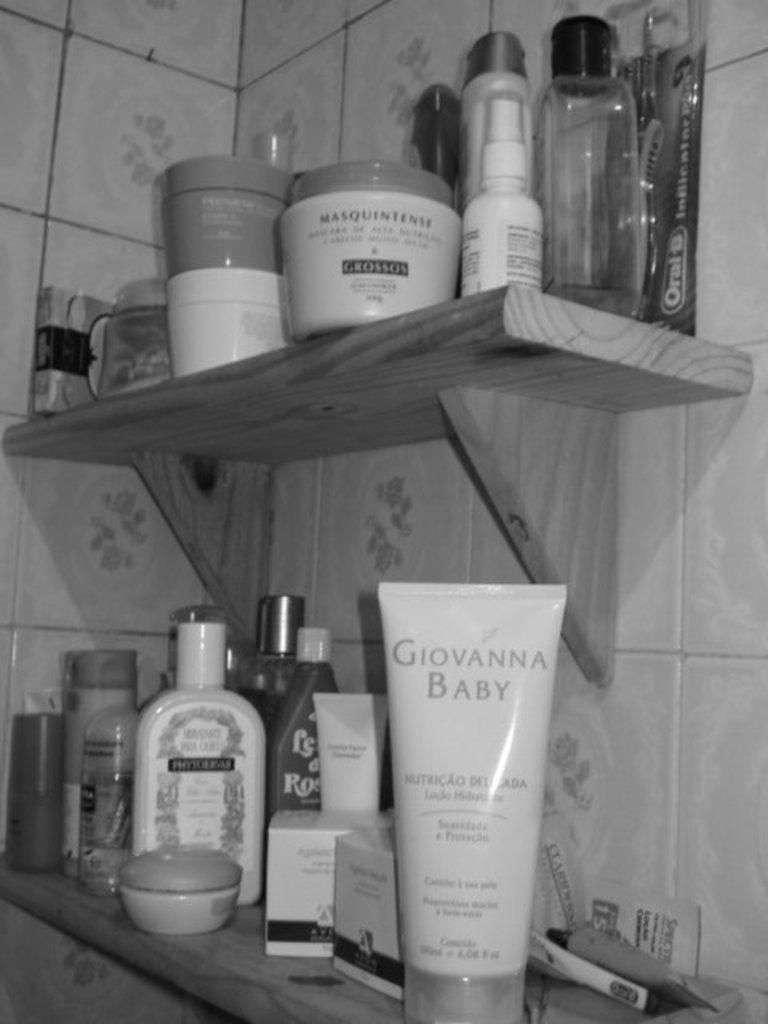In one or two sentences, can you explain what this image depicts? This is a black and white picture. Here we can see bottles, boxes, and other objects on the shelves. In the background we can see wall. 